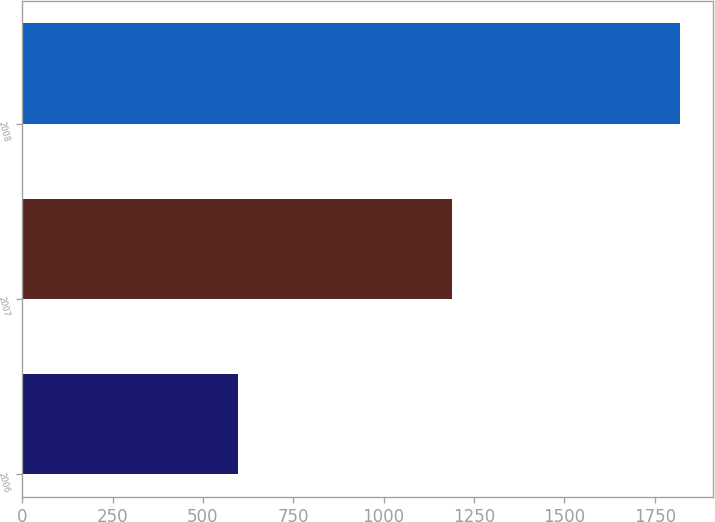<chart> <loc_0><loc_0><loc_500><loc_500><bar_chart><fcel>2006<fcel>2007<fcel>2008<nl><fcel>597<fcel>1189<fcel>1819<nl></chart> 